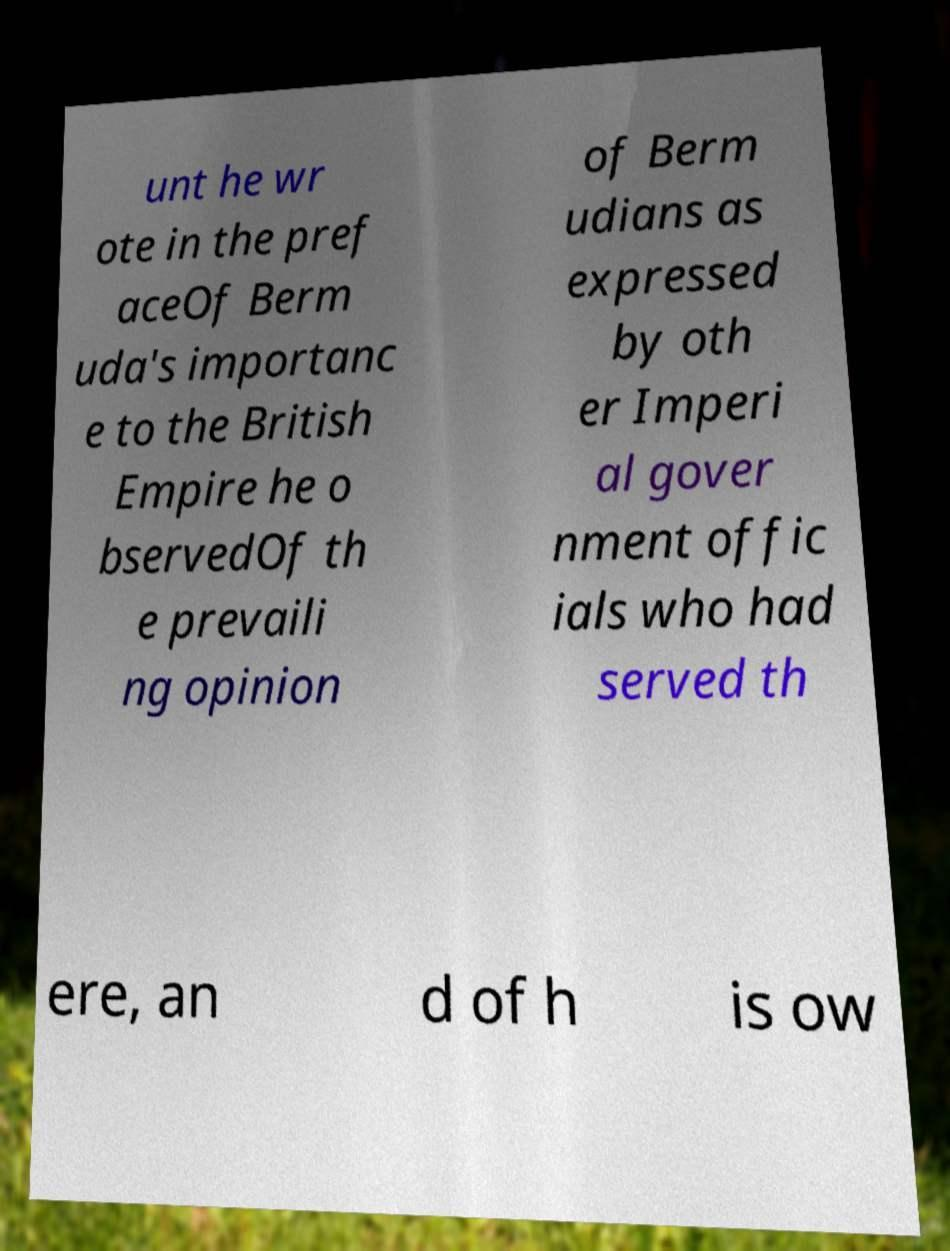Please read and relay the text visible in this image. What does it say? unt he wr ote in the pref aceOf Berm uda's importanc e to the British Empire he o bservedOf th e prevaili ng opinion of Berm udians as expressed by oth er Imperi al gover nment offic ials who had served th ere, an d of h is ow 